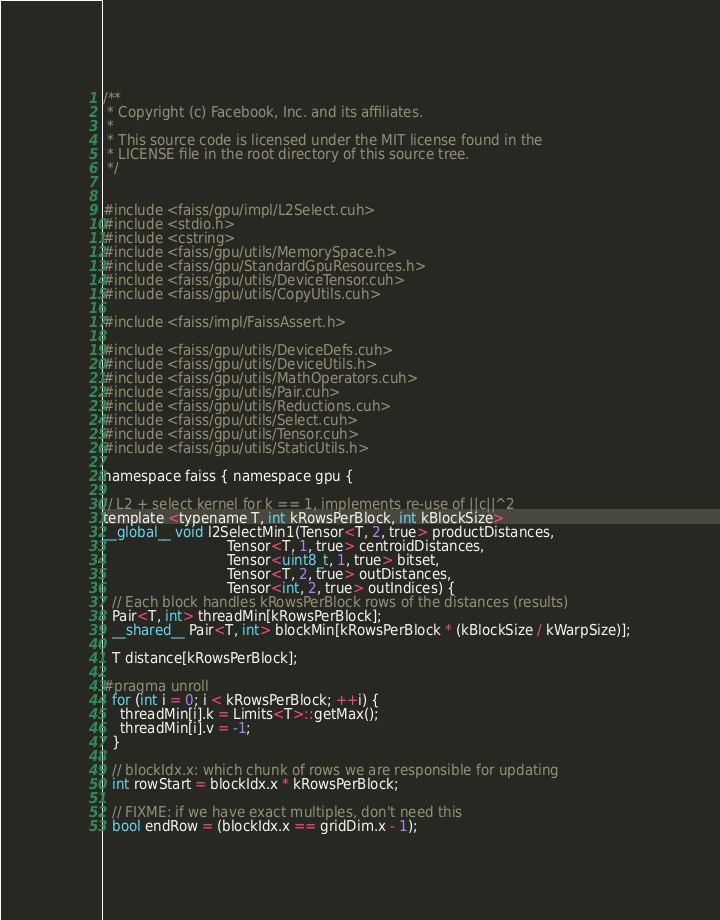<code> <loc_0><loc_0><loc_500><loc_500><_Cuda_>/**
 * Copyright (c) Facebook, Inc. and its affiliates.
 *
 * This source code is licensed under the MIT license found in the
 * LICENSE file in the root directory of this source tree.
 */


#include <faiss/gpu/impl/L2Select.cuh>
#include <stdio.h>
#include <cstring>
#include <faiss/gpu/utils/MemorySpace.h>
#include <faiss/gpu/StandardGpuResources.h>
#include <faiss/gpu/utils/DeviceTensor.cuh>
#include <faiss/gpu/utils/CopyUtils.cuh>

#include <faiss/impl/FaissAssert.h>

#include <faiss/gpu/utils/DeviceDefs.cuh>
#include <faiss/gpu/utils/DeviceUtils.h>
#include <faiss/gpu/utils/MathOperators.cuh>
#include <faiss/gpu/utils/Pair.cuh>
#include <faiss/gpu/utils/Reductions.cuh>
#include <faiss/gpu/utils/Select.cuh>
#include <faiss/gpu/utils/Tensor.cuh>
#include <faiss/gpu/utils/StaticUtils.h>

namespace faiss { namespace gpu {

// L2 + select kernel for k == 1, implements re-use of ||c||^2
template <typename T, int kRowsPerBlock, int kBlockSize>
__global__ void l2SelectMin1(Tensor<T, 2, true> productDistances,
                             Tensor<T, 1, true> centroidDistances,
                             Tensor<uint8_t, 1, true> bitset,
                             Tensor<T, 2, true> outDistances,
                             Tensor<int, 2, true> outIndices) {
  // Each block handles kRowsPerBlock rows of the distances (results)
  Pair<T, int> threadMin[kRowsPerBlock];
  __shared__ Pair<T, int> blockMin[kRowsPerBlock * (kBlockSize / kWarpSize)];

  T distance[kRowsPerBlock];

#pragma unroll
  for (int i = 0; i < kRowsPerBlock; ++i) {
    threadMin[i].k = Limits<T>::getMax();
    threadMin[i].v = -1;
  }

  // blockIdx.x: which chunk of rows we are responsible for updating
  int rowStart = blockIdx.x * kRowsPerBlock;

  // FIXME: if we have exact multiples, don't need this
  bool endRow = (blockIdx.x == gridDim.x - 1);
</code> 